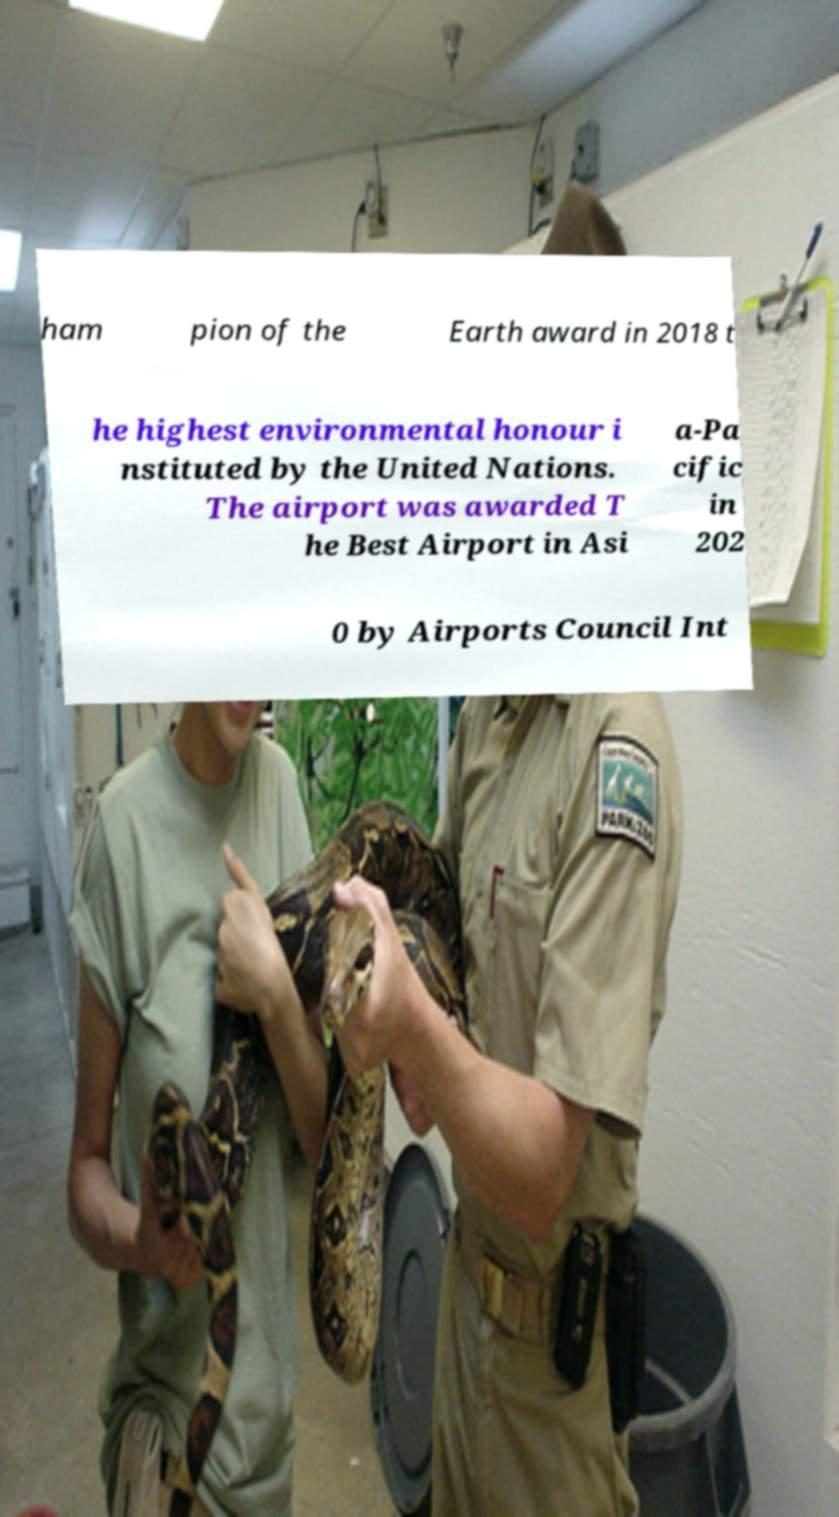There's text embedded in this image that I need extracted. Can you transcribe it verbatim? ham pion of the Earth award in 2018 t he highest environmental honour i nstituted by the United Nations. The airport was awarded T he Best Airport in Asi a-Pa cific in 202 0 by Airports Council Int 